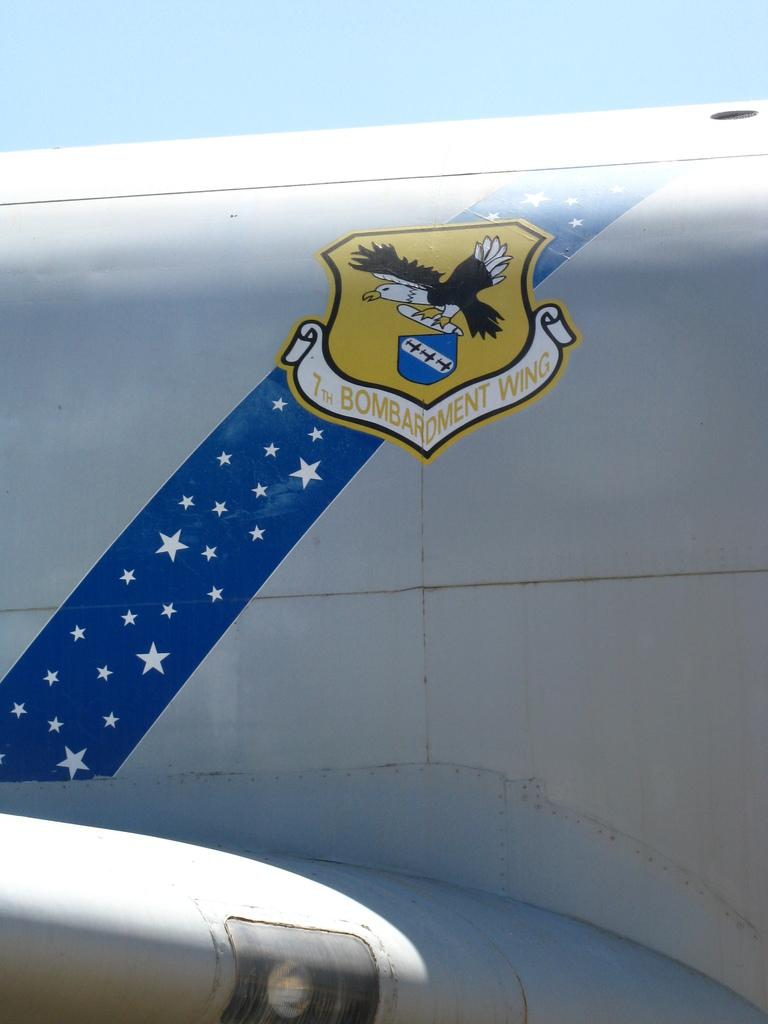<image>
Write a terse but informative summary of the picture. The outside of an airplane with a logo of an eagle with the saying 7th Bombardment Wings and a long blue strips with starts on the side of the airplane. 